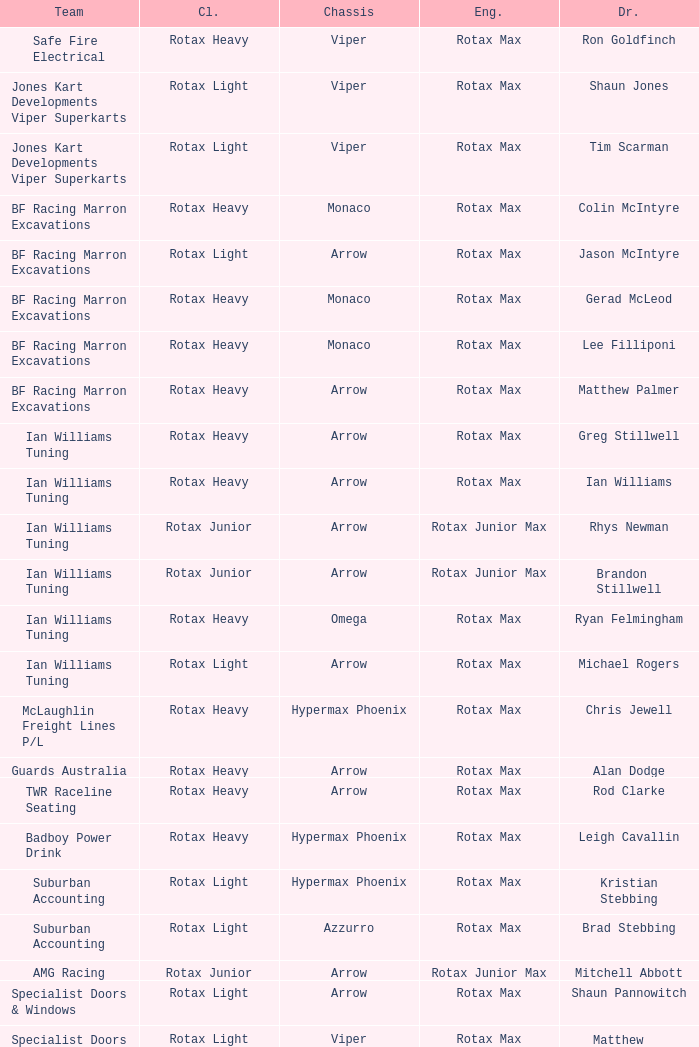What type of engine does the BF Racing Marron Excavations have that also has Monaco as chassis and Lee Filliponi as the driver? Rotax Max. 